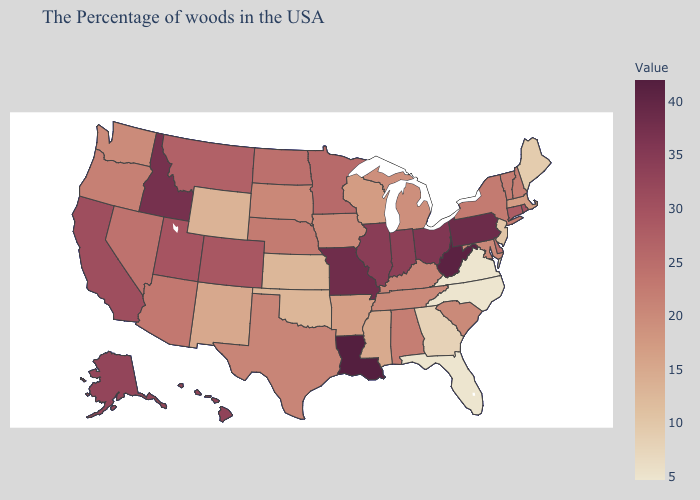Does Kansas have the lowest value in the MidWest?
Give a very brief answer. Yes. Which states have the lowest value in the Northeast?
Concise answer only. Maine. Does Alaska have the highest value in the West?
Write a very short answer. No. Among the states that border Minnesota , does Iowa have the highest value?
Answer briefly. No. 